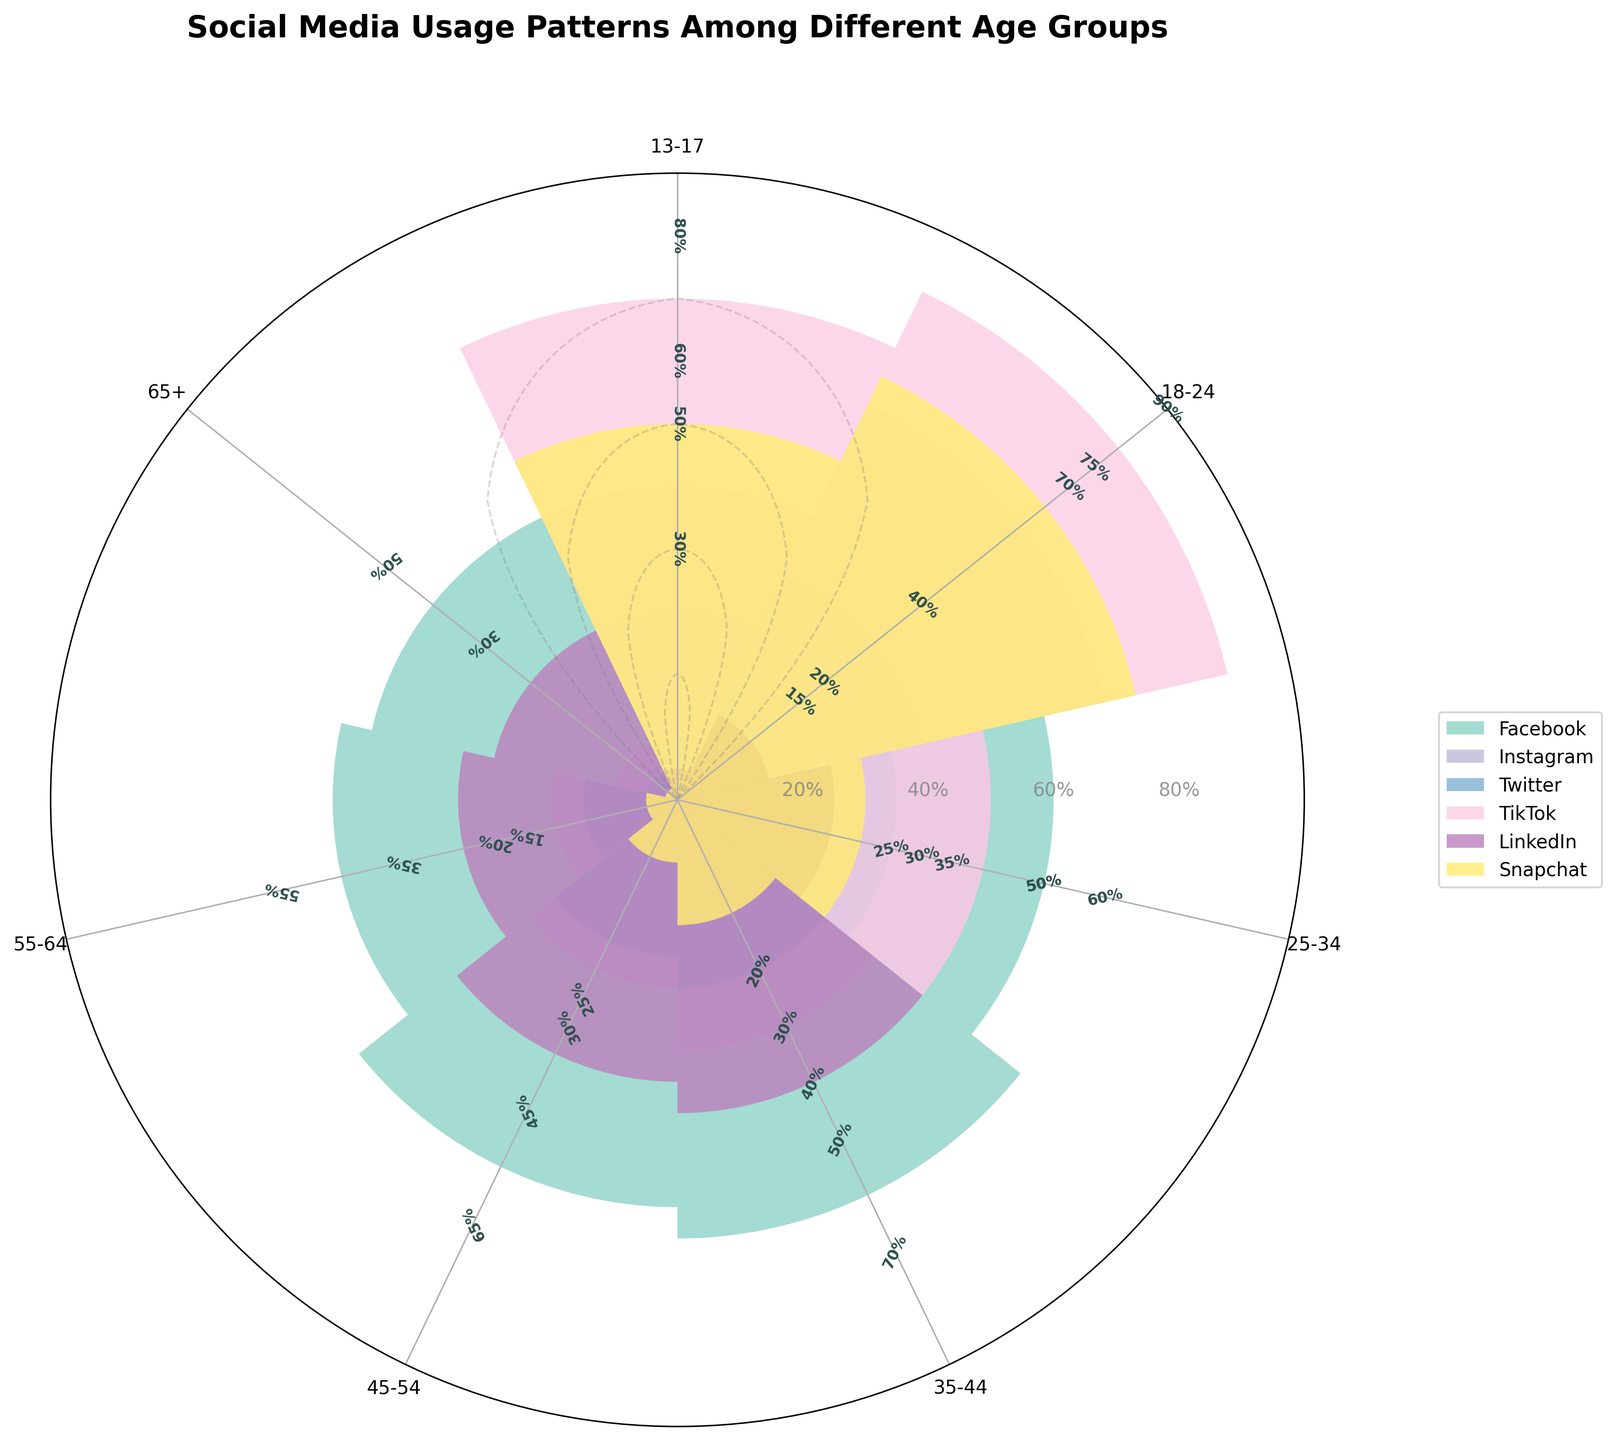What is the title of the rose chart? The title of the rose chart is written at the top of the figure in a bold and larger font. It helps to understand what the chart represents.
Answer: Social Media Usage Patterns Among Different Age Groups Which social media platform has the highest usage among the 13-17 age group? By looking at the largest bar segment for the 13-17 age group, we can see that TikTok has the highest usage, as it stretches the farthest out in the radial direction.
Answer: TikTok What's the difference in Facebook usage between the 25-34 and 45-54 age groups? Examine the radial length of the bars corresponding to Facebook for both age groups and subtract the usage percentage. The values are 60% for the 25-34 group and 65% for the 45-54 group. So, the difference is 65 - 60 = 5%.
Answer: 5% Which age group has the lowest Instagram usage? Compare the radial lengths of the bars corresponding to Instagram across all age groups. The 65+ group has the shortest bar for Instagram, indicating the lowest usage.
Answer: 65+ How many social media platforms are displayed in the rose chart? Count the number of distinct colors and labels represented in the legend of the figure. Each color and label represent a social media platform. There are six colors/labels.
Answer: 6 Which age group uses LinkedIn the most? Look for the longest bar segment in the LinkedIn category across all age groups. The 35-44 age group has the longest bar for LinkedIn.
Answer: 35-44 Compare TikTok usage between the 18-24 and 55-64 age groups. How much more is it used by the 18-24 age group? Find the bar lengths for TikTok for both age groups. The 18-24 age group has 90% usage, and the 55-64 age group has 5% usage. Then, subtract the two percentages to get the difference, which is 90 - 5 = 85%.
Answer: 85% What is the average Snapchat usage across all age groups? Sum the Snapchat usage percentages for all age groups and then divide by the number of age groups. The values are 60, 75, 30, 20, 10, 5, and 2. The sum is 202, and there are 7 age groups. So, the average usage is 202 / 7 ≈ 28.86%.
Answer: 28.86% Which social media platform is the least used by the 45-54 age group? Look for the shortest bar segment in the 45-54 age group's radial section. The bar for Snapchat is the shortest, indicating the least usage.
Answer: Snapchat 